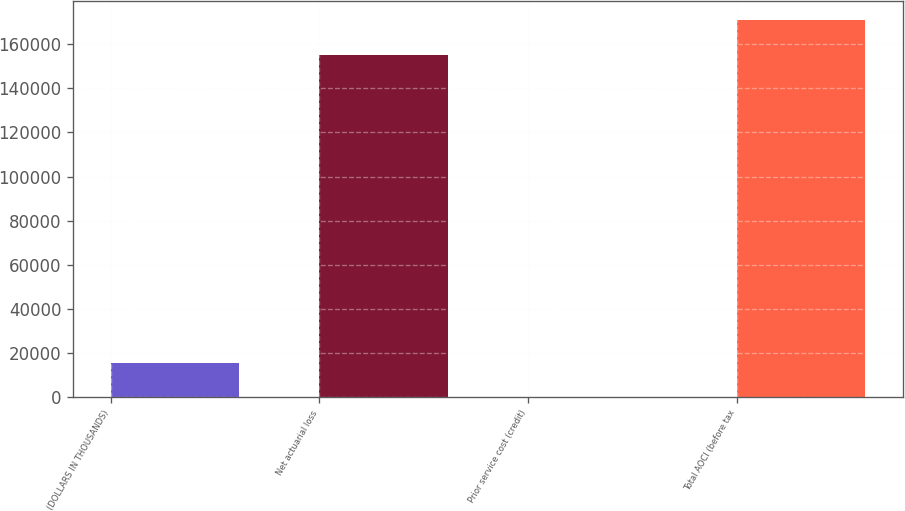Convert chart. <chart><loc_0><loc_0><loc_500><loc_500><bar_chart><fcel>(DOLLARS IN THOUSANDS)<fcel>Net actuarial loss<fcel>Prior service cost (credit)<fcel>Total AOCI (before tax<nl><fcel>15547.5<fcel>155305<fcel>17<fcel>170836<nl></chart> 